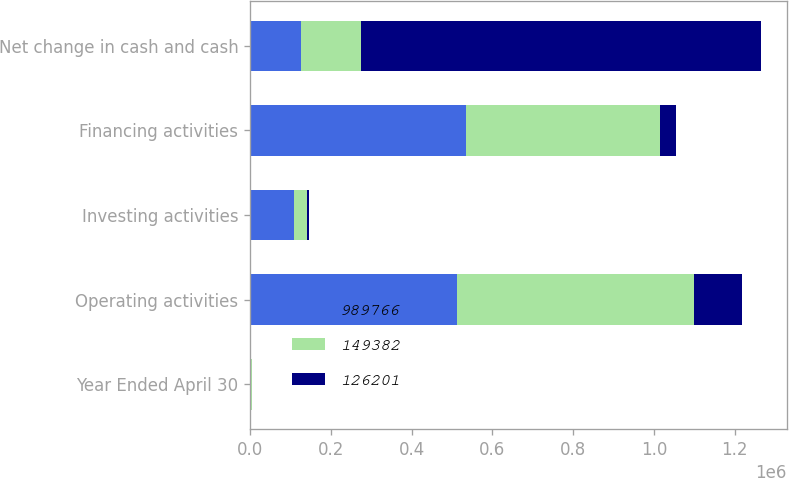Convert chart. <chart><loc_0><loc_0><loc_500><loc_500><stacked_bar_chart><ecel><fcel>Year Ended April 30<fcel>Operating activities<fcel>Investing activities<fcel>Financing activities<fcel>Net change in cash and cash<nl><fcel>989766<fcel>2011<fcel>512503<fcel>110157<fcel>534391<fcel>126201<nl><fcel>149382<fcel>2010<fcel>587469<fcel>31353<fcel>481118<fcel>149382<nl><fcel>126201<fcel>2009<fcel>118179<fcel>5560<fcel>40233<fcel>989766<nl></chart> 